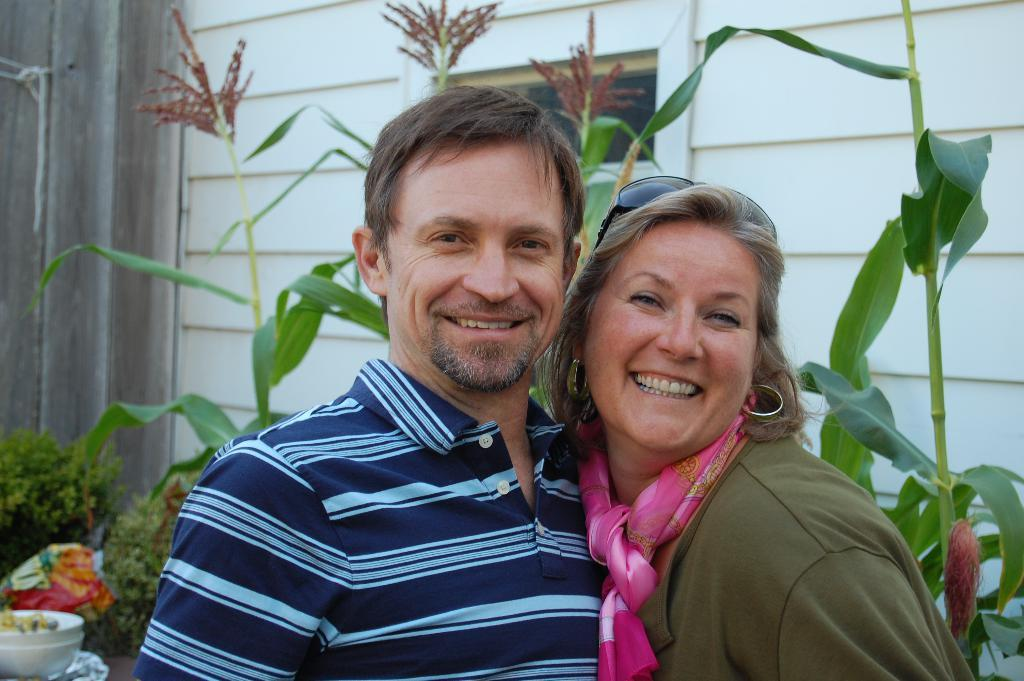Who is present in the image? There is a man and a woman in the image. What are the facial expressions of the people in the image? The man and the woman are both smiling. What is the man wearing in the image? The man is wearing a t-shirt. What can be seen in the background of the image? There are plants visible in the background of the image. How many books can be seen on the table in the image? There is no table or books present in the image. What color is the sky in the image? The provided facts do not mention the sky, so we cannot determine its color from the image. 